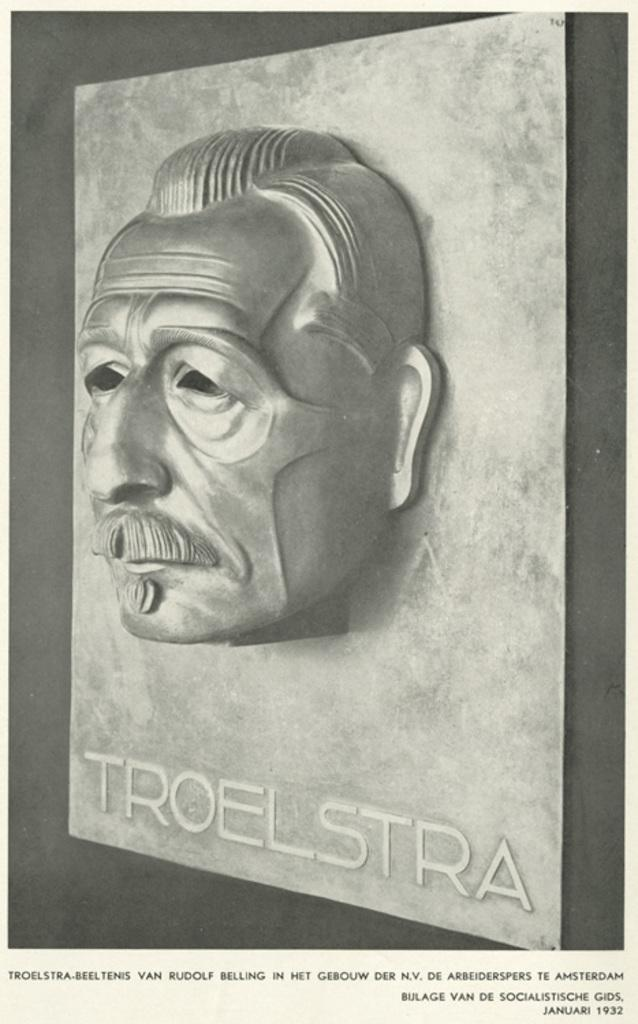What is the color scheme of the image? The image is black and white. What is the main subject of the image? There is a sculpture of a person's face in the image. What is the chance of winning a prize in the image? There is no reference to a prize or winning in the image, as it features a black and white sculpture of a person's face. What act is being performed by the person in the image? The image is a sculpture, so there is no actual person performing an act; it is a static representation of a person's face. 